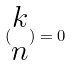Convert formula to latex. <formula><loc_0><loc_0><loc_500><loc_500>( \begin{matrix} k \\ n \end{matrix} ) = 0</formula> 